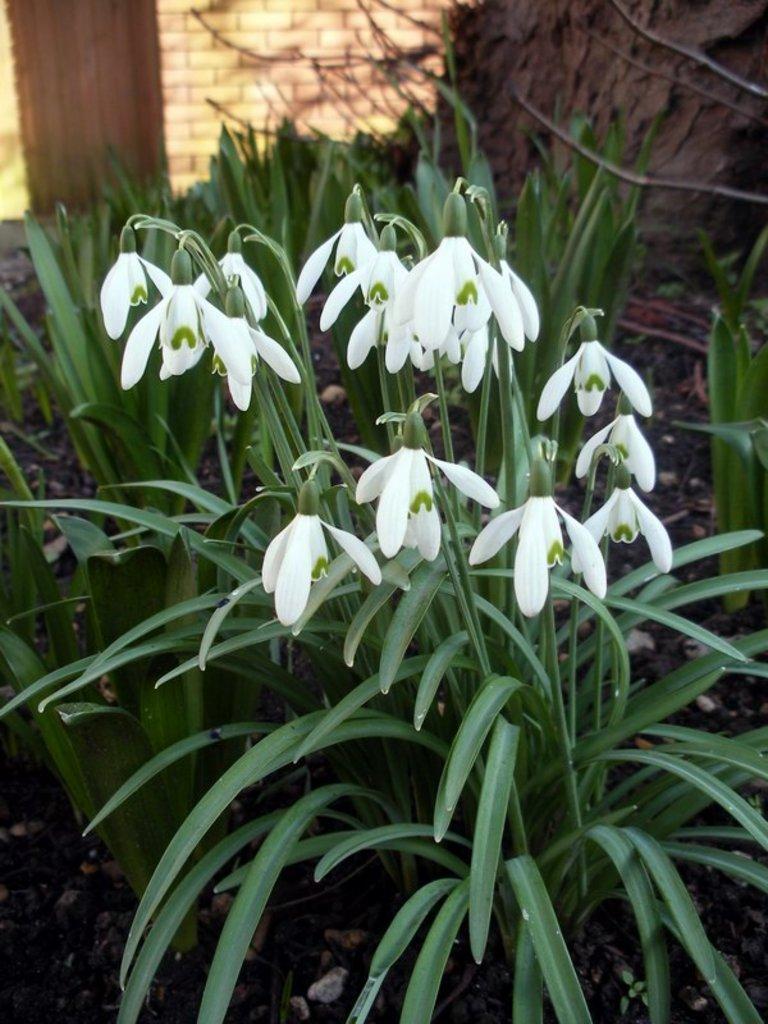How would you summarize this image in a sentence or two? As we can see in the image there are plants, white color flowers and wall. 